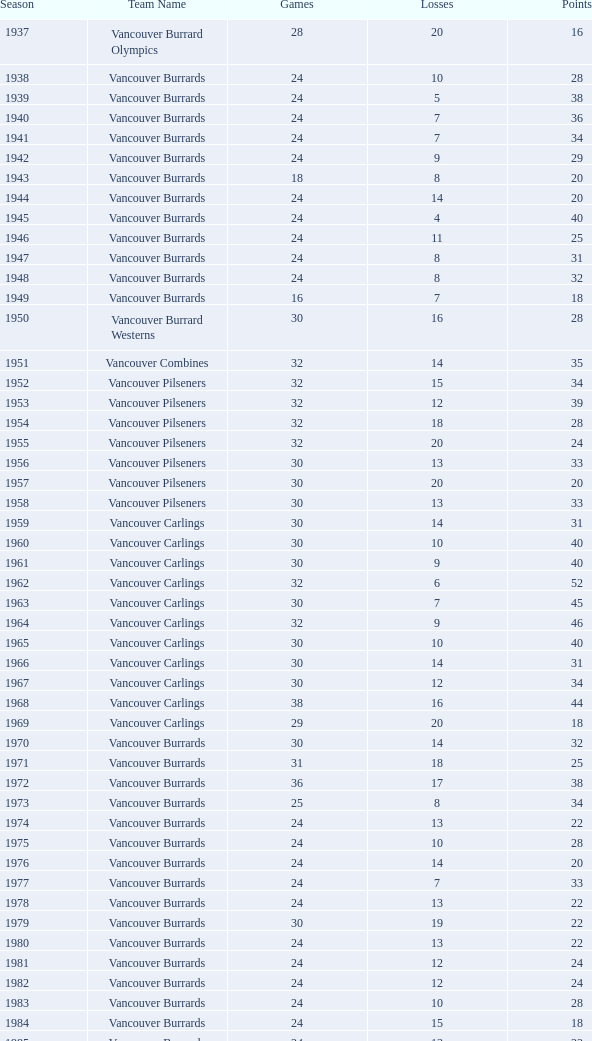What's the aggregate of points for the 1963 season when there are in excess of 30 games? None. Give me the full table as a dictionary. {'header': ['Season', 'Team Name', 'Games', 'Losses', 'Points'], 'rows': [['1937', 'Vancouver Burrard Olympics', '28', '20', '16'], ['1938', 'Vancouver Burrards', '24', '10', '28'], ['1939', 'Vancouver Burrards', '24', '5', '38'], ['1940', 'Vancouver Burrards', '24', '7', '36'], ['1941', 'Vancouver Burrards', '24', '7', '34'], ['1942', 'Vancouver Burrards', '24', '9', '29'], ['1943', 'Vancouver Burrards', '18', '8', '20'], ['1944', 'Vancouver Burrards', '24', '14', '20'], ['1945', 'Vancouver Burrards', '24', '4', '40'], ['1946', 'Vancouver Burrards', '24', '11', '25'], ['1947', 'Vancouver Burrards', '24', '8', '31'], ['1948', 'Vancouver Burrards', '24', '8', '32'], ['1949', 'Vancouver Burrards', '16', '7', '18'], ['1950', 'Vancouver Burrard Westerns', '30', '16', '28'], ['1951', 'Vancouver Combines', '32', '14', '35'], ['1952', 'Vancouver Pilseners', '32', '15', '34'], ['1953', 'Vancouver Pilseners', '32', '12', '39'], ['1954', 'Vancouver Pilseners', '32', '18', '28'], ['1955', 'Vancouver Pilseners', '32', '20', '24'], ['1956', 'Vancouver Pilseners', '30', '13', '33'], ['1957', 'Vancouver Pilseners', '30', '20', '20'], ['1958', 'Vancouver Pilseners', '30', '13', '33'], ['1959', 'Vancouver Carlings', '30', '14', '31'], ['1960', 'Vancouver Carlings', '30', '10', '40'], ['1961', 'Vancouver Carlings', '30', '9', '40'], ['1962', 'Vancouver Carlings', '32', '6', '52'], ['1963', 'Vancouver Carlings', '30', '7', '45'], ['1964', 'Vancouver Carlings', '32', '9', '46'], ['1965', 'Vancouver Carlings', '30', '10', '40'], ['1966', 'Vancouver Carlings', '30', '14', '31'], ['1967', 'Vancouver Carlings', '30', '12', '34'], ['1968', 'Vancouver Carlings', '38', '16', '44'], ['1969', 'Vancouver Carlings', '29', '20', '18'], ['1970', 'Vancouver Burrards', '30', '14', '32'], ['1971', 'Vancouver Burrards', '31', '18', '25'], ['1972', 'Vancouver Burrards', '36', '17', '38'], ['1973', 'Vancouver Burrards', '25', '8', '34'], ['1974', 'Vancouver Burrards', '24', '13', '22'], ['1975', 'Vancouver Burrards', '24', '10', '28'], ['1976', 'Vancouver Burrards', '24', '14', '20'], ['1977', 'Vancouver Burrards', '24', '7', '33'], ['1978', 'Vancouver Burrards', '24', '13', '22'], ['1979', 'Vancouver Burrards', '30', '19', '22'], ['1980', 'Vancouver Burrards', '24', '13', '22'], ['1981', 'Vancouver Burrards', '24', '12', '24'], ['1982', 'Vancouver Burrards', '24', '12', '24'], ['1983', 'Vancouver Burrards', '24', '10', '28'], ['1984', 'Vancouver Burrards', '24', '15', '18'], ['1985', 'Vancouver Burrards', '24', '13', '22'], ['1986', 'Vancouver Burrards', '24', '11', '26'], ['1987', 'Vancouver Burrards', '24', '14', '20'], ['1988', 'Vancouver Burrards', '24', '13', '22'], ['1989', 'Vancouver Burrards', '24', '15', '18'], ['1990', 'Vancouver Burrards', '24', '8', '32'], ['1991', 'Vancouver Burrards', '24', '16', '16'], ['1992', 'Vancouver Burrards', '24', '15', '18'], ['1993', 'Vancouver Burrards', '24', '20', '8'], ['1994', 'Surrey Burrards', '20', '12', '16'], ['1995', 'Surrey Burrards', '25', '19', '11'], ['1996', 'Maple Ridge Burrards', '20', '8', '23'], ['1997', 'Maple Ridge Burrards', '20', '8', '23'], ['1998', 'Maple Ridge Burrards', '25', '8', '32'], ['1999', 'Maple Ridge Burrards', '25', '15', '20'], ['2000', 'Maple Ridge Burrards', '25', '16', '18'], ['2001', 'Maple Ridge Burrards', '20', '16', '8'], ['2002', 'Maple Ridge Burrards', '20', '15', '8'], ['2003', 'Maple Ridge Burrards', '20', '15', '10'], ['2004', 'Maple Ridge Burrards', '20', '12', '16'], ['2005', 'Maple Ridge Burrards', '18', '8', '19'], ['2006', 'Maple Ridge Burrards', '18', '11', '14'], ['2007', 'Maple Ridge Burrards', '18', '11', '14'], ['2008', 'Maple Ridge Burrards', '18', '13', '10'], ['2009', 'Maple Ridge Burrards', '18', '11', '14'], ['2010', 'Maple Ridge Burrards', '18', '9', '18'], ['Total', '74 seasons', '1,879', '913', '1,916']]} 